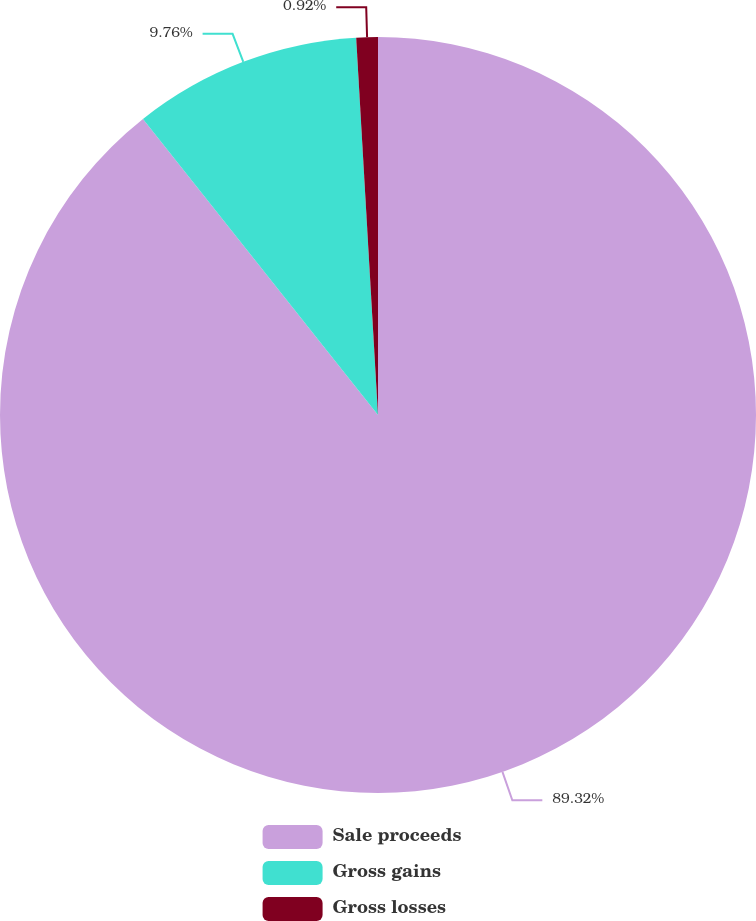<chart> <loc_0><loc_0><loc_500><loc_500><pie_chart><fcel>Sale proceeds<fcel>Gross gains<fcel>Gross losses<nl><fcel>89.32%<fcel>9.76%<fcel>0.92%<nl></chart> 